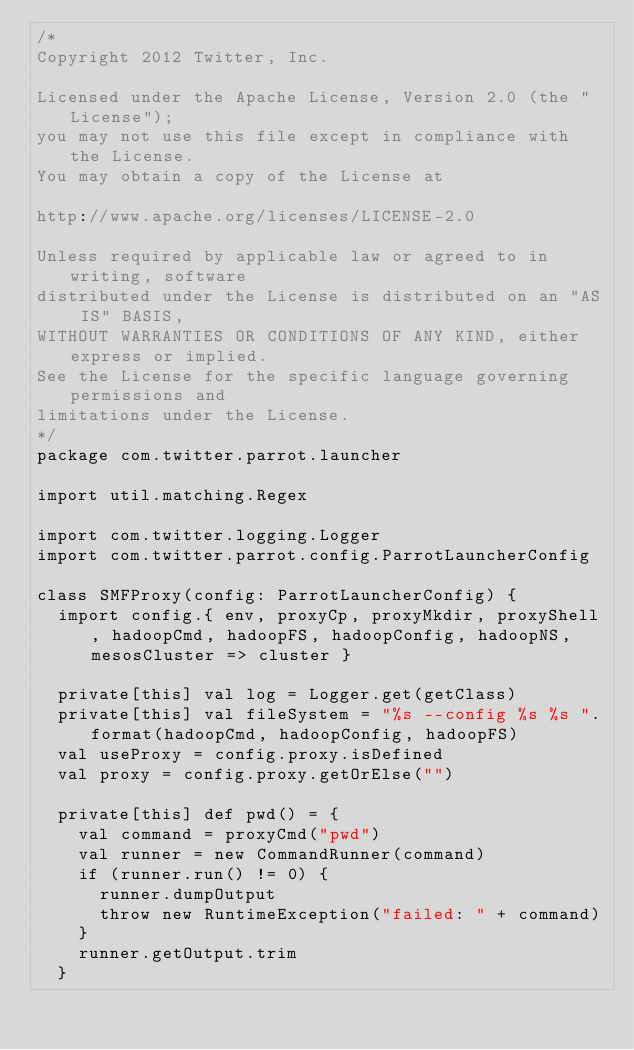Convert code to text. <code><loc_0><loc_0><loc_500><loc_500><_Scala_>/*
Copyright 2012 Twitter, Inc.

Licensed under the Apache License, Version 2.0 (the "License");
you may not use this file except in compliance with the License.
You may obtain a copy of the License at

http://www.apache.org/licenses/LICENSE-2.0

Unless required by applicable law or agreed to in writing, software
distributed under the License is distributed on an "AS IS" BASIS,
WITHOUT WARRANTIES OR CONDITIONS OF ANY KIND, either express or implied.
See the License for the specific language governing permissions and
limitations under the License.
*/
package com.twitter.parrot.launcher

import util.matching.Regex

import com.twitter.logging.Logger
import com.twitter.parrot.config.ParrotLauncherConfig

class SMFProxy(config: ParrotLauncherConfig) {
  import config.{ env, proxyCp, proxyMkdir, proxyShell, hadoopCmd, hadoopFS, hadoopConfig, hadoopNS, mesosCluster => cluster }

  private[this] val log = Logger.get(getClass)
  private[this] val fileSystem = "%s --config %s %s ".format(hadoopCmd, hadoopConfig, hadoopFS)
  val useProxy = config.proxy.isDefined
  val proxy = config.proxy.getOrElse("")

  private[this] def pwd() = {
    val command = proxyCmd("pwd")
    val runner = new CommandRunner(command)
    if (runner.run() != 0) {
      runner.dumpOutput
      throw new RuntimeException("failed: " + command)
    }
    runner.getOutput.trim
  }
</code> 